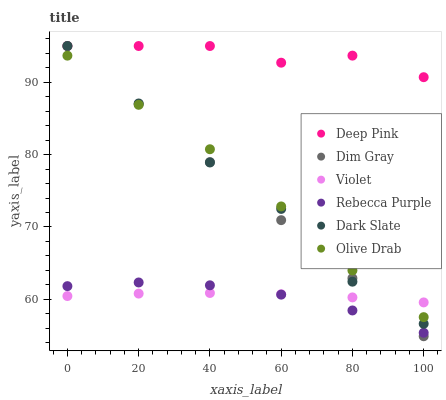Does Rebecca Purple have the minimum area under the curve?
Answer yes or no. Yes. Does Deep Pink have the maximum area under the curve?
Answer yes or no. Yes. Does Dark Slate have the minimum area under the curve?
Answer yes or no. No. Does Dark Slate have the maximum area under the curve?
Answer yes or no. No. Is Dim Gray the smoothest?
Answer yes or no. Yes. Is Dark Slate the roughest?
Answer yes or no. Yes. Is Deep Pink the smoothest?
Answer yes or no. No. Is Deep Pink the roughest?
Answer yes or no. No. Does Dim Gray have the lowest value?
Answer yes or no. Yes. Does Dark Slate have the lowest value?
Answer yes or no. No. Does Deep Pink have the highest value?
Answer yes or no. Yes. Does Rebecca Purple have the highest value?
Answer yes or no. No. Is Rebecca Purple less than Dark Slate?
Answer yes or no. Yes. Is Deep Pink greater than Violet?
Answer yes or no. Yes. Does Violet intersect Dim Gray?
Answer yes or no. Yes. Is Violet less than Dim Gray?
Answer yes or no. No. Is Violet greater than Dim Gray?
Answer yes or no. No. Does Rebecca Purple intersect Dark Slate?
Answer yes or no. No. 